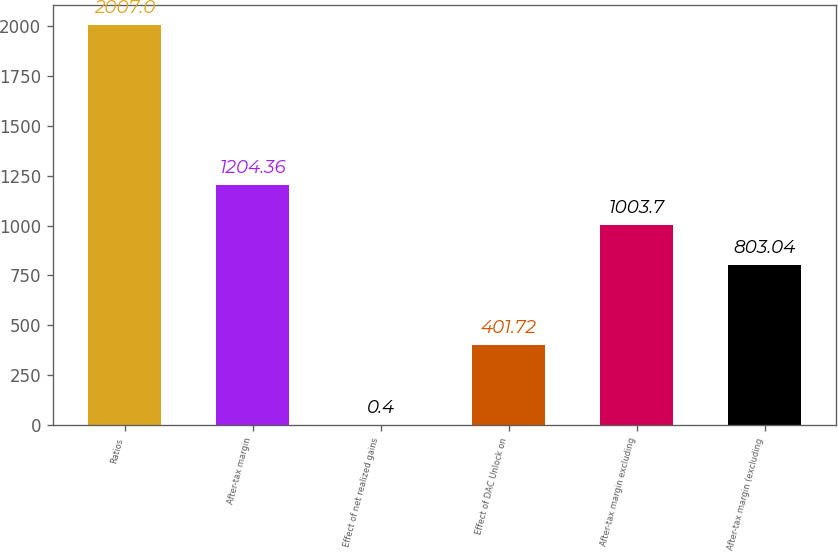Convert chart to OTSL. <chart><loc_0><loc_0><loc_500><loc_500><bar_chart><fcel>Ratios<fcel>After-tax margin<fcel>Effect of net realized gains<fcel>Effect of DAC Unlock on<fcel>After-tax margin excluding<fcel>After-tax margin (excluding<nl><fcel>2007<fcel>1204.36<fcel>0.4<fcel>401.72<fcel>1003.7<fcel>803.04<nl></chart> 